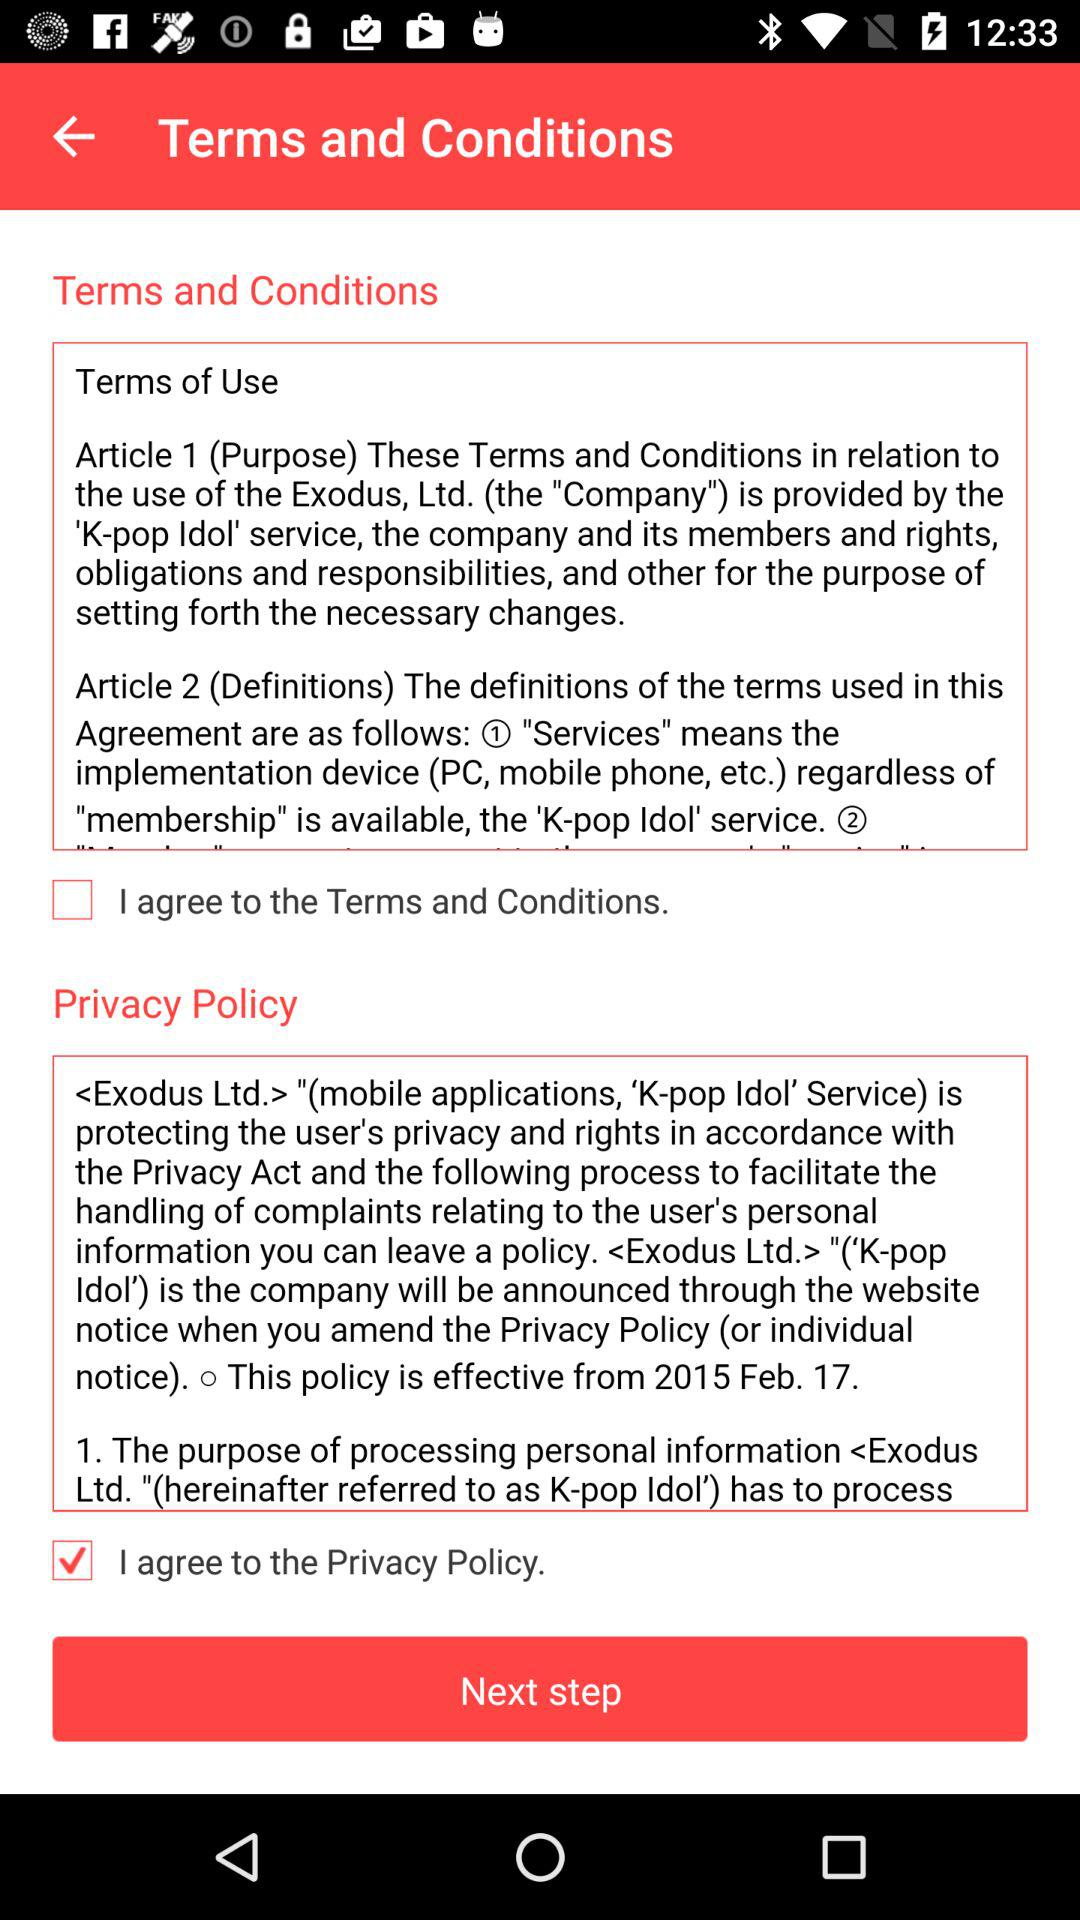What is the current state of "I agree to the Privacy Policy"? The status is "on". 